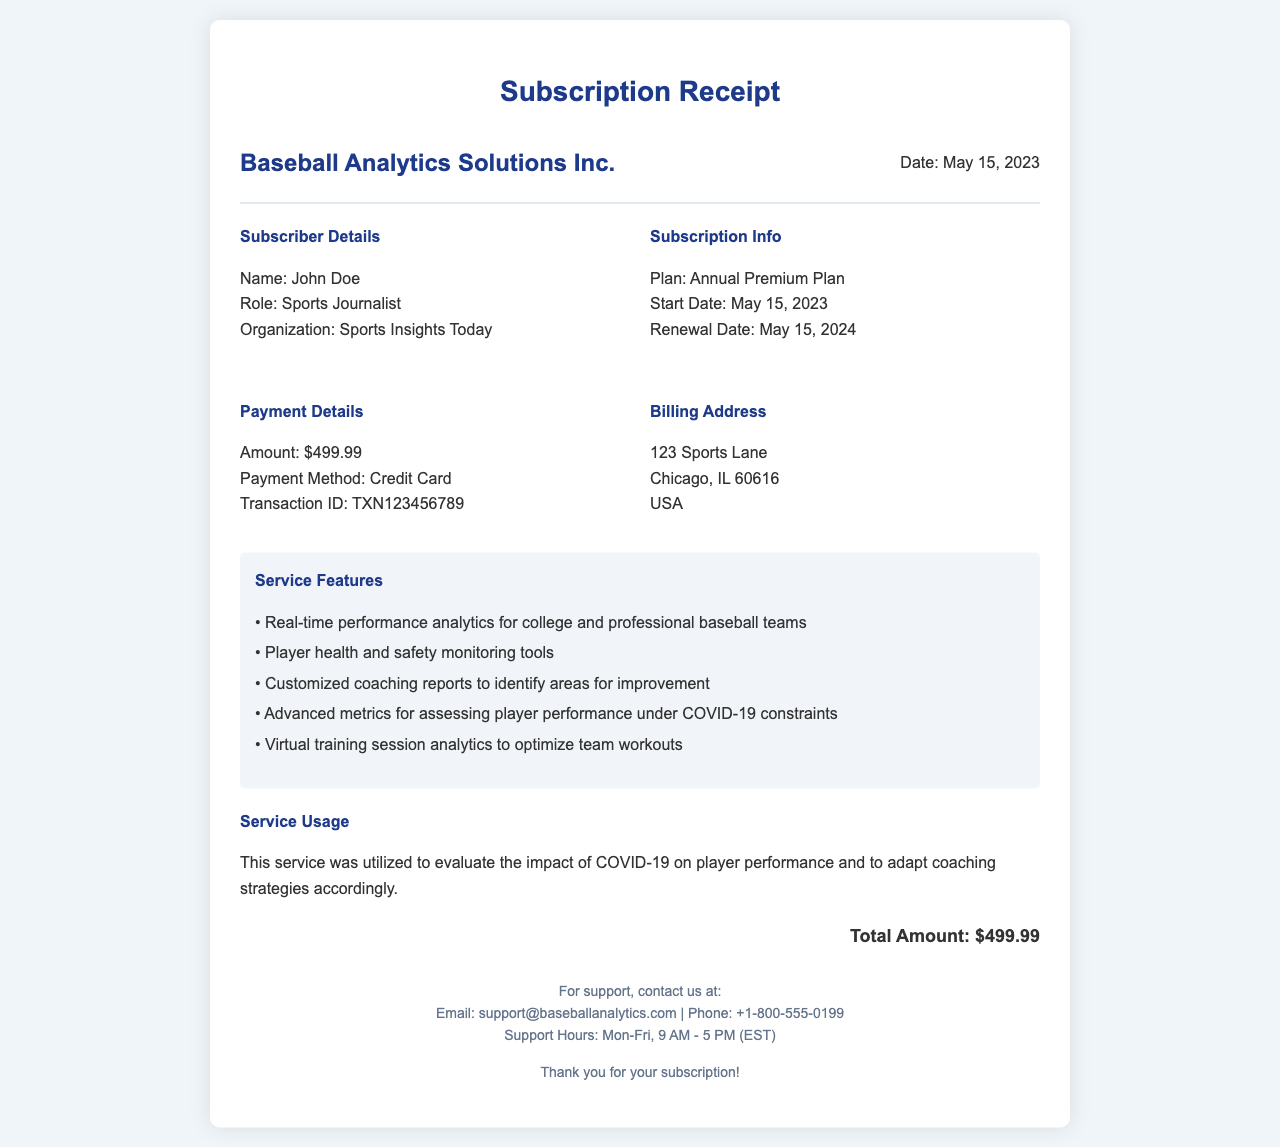What is the name of the company? The name of the company is listed at the top of the receipt.
Answer: Baseball Analytics Solutions Inc What is the subscription plan? The document specifies what subscription plan was purchased.
Answer: Annual Premium Plan What is the amount paid? The receipt clearly states the total amount charged for the subscription.
Answer: $499.99 When does the subscription renewal date occur? The renewal date is provided in the subscription info section of the document.
Answer: May 15, 2024 Who is the subscriber? The subscriber's details are mentioned in the receipt under "Subscriber Details."
Answer: John Doe What transaction ID is associated with the payment? The transaction ID is provided in the payment details section of the receipt.
Answer: TXN123456789 What is one feature included in the service? The service features are listed, and one can be selected as an example.
Answer: Real-time performance analytics for college and professional baseball teams How was the service utilized? The document outlines the purpose of the service in the "Service Usage" section.
Answer: To evaluate the impact of COVID-19 on player performance What is the billing address of the subscriber? The billing address is provided in its own section on the receipt.
Answer: 123 Sports Lane, Chicago, IL 60616, USA What tools are mentioned for player health monitoring? Specific features related to health monitoring are mentioned in the features section.
Answer: Player health and safety monitoring tools 